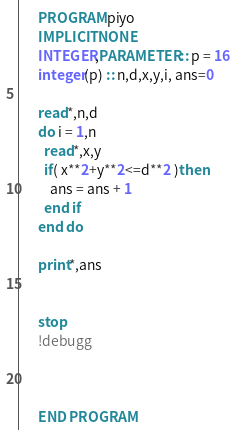<code> <loc_0><loc_0><loc_500><loc_500><_FORTRAN_>      PROGRAM piyo
      IMPLICIT NONE
      INTEGER,PARAMETER :: p = 16
      integer(p) :: n,d,x,y,i, ans=0
      
      read*,n,d
      do i = 1,n
        read*,x,y
        if( x**2+y**2<=d**2 )then
          ans = ans + 1
        end if
      end do
      
      print*,ans
      
      
      stop
      !debugg
      
      
      
      END PROGRAM</code> 